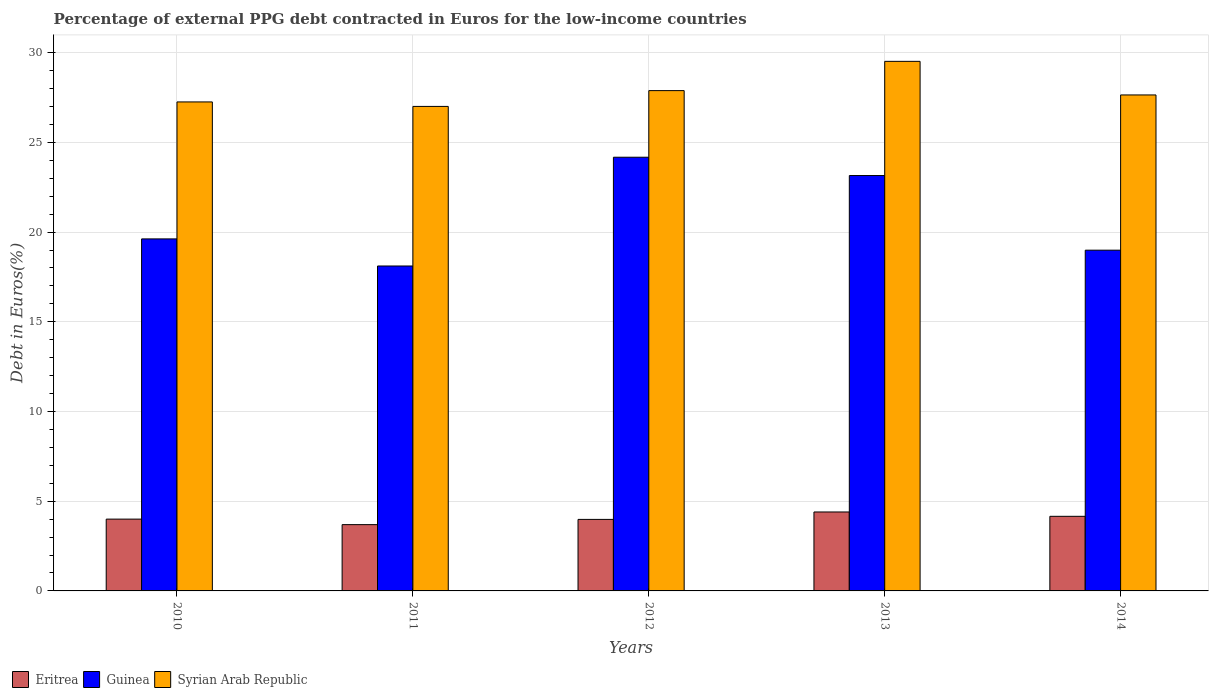How many different coloured bars are there?
Your answer should be very brief. 3. How many bars are there on the 1st tick from the right?
Provide a short and direct response. 3. In how many cases, is the number of bars for a given year not equal to the number of legend labels?
Offer a terse response. 0. What is the percentage of external PPG debt contracted in Euros in Syrian Arab Republic in 2011?
Provide a succinct answer. 27. Across all years, what is the maximum percentage of external PPG debt contracted in Euros in Guinea?
Provide a succinct answer. 24.17. Across all years, what is the minimum percentage of external PPG debt contracted in Euros in Syrian Arab Republic?
Offer a very short reply. 27. What is the total percentage of external PPG debt contracted in Euros in Guinea in the graph?
Make the answer very short. 104.04. What is the difference between the percentage of external PPG debt contracted in Euros in Syrian Arab Republic in 2012 and that in 2013?
Keep it short and to the point. -1.63. What is the difference between the percentage of external PPG debt contracted in Euros in Syrian Arab Republic in 2010 and the percentage of external PPG debt contracted in Euros in Guinea in 2014?
Offer a very short reply. 8.26. What is the average percentage of external PPG debt contracted in Euros in Syrian Arab Republic per year?
Your response must be concise. 27.86. In the year 2012, what is the difference between the percentage of external PPG debt contracted in Euros in Eritrea and percentage of external PPG debt contracted in Euros in Syrian Arab Republic?
Your answer should be compact. -23.9. What is the ratio of the percentage of external PPG debt contracted in Euros in Guinea in 2010 to that in 2012?
Your response must be concise. 0.81. Is the percentage of external PPG debt contracted in Euros in Guinea in 2013 less than that in 2014?
Your answer should be compact. No. What is the difference between the highest and the second highest percentage of external PPG debt contracted in Euros in Syrian Arab Republic?
Make the answer very short. 1.63. What is the difference between the highest and the lowest percentage of external PPG debt contracted in Euros in Eritrea?
Your answer should be compact. 0.71. What does the 3rd bar from the left in 2013 represents?
Keep it short and to the point. Syrian Arab Republic. What does the 2nd bar from the right in 2012 represents?
Offer a very short reply. Guinea. Are all the bars in the graph horizontal?
Provide a short and direct response. No. Are the values on the major ticks of Y-axis written in scientific E-notation?
Keep it short and to the point. No. How many legend labels are there?
Give a very brief answer. 3. What is the title of the graph?
Give a very brief answer. Percentage of external PPG debt contracted in Euros for the low-income countries. Does "Lithuania" appear as one of the legend labels in the graph?
Offer a terse response. No. What is the label or title of the Y-axis?
Your response must be concise. Debt in Euros(%). What is the Debt in Euros(%) of Eritrea in 2010?
Your response must be concise. 4. What is the Debt in Euros(%) of Guinea in 2010?
Your response must be concise. 19.62. What is the Debt in Euros(%) in Syrian Arab Republic in 2010?
Make the answer very short. 27.25. What is the Debt in Euros(%) in Eritrea in 2011?
Keep it short and to the point. 3.69. What is the Debt in Euros(%) of Guinea in 2011?
Offer a very short reply. 18.11. What is the Debt in Euros(%) in Syrian Arab Republic in 2011?
Offer a terse response. 27. What is the Debt in Euros(%) of Eritrea in 2012?
Your response must be concise. 3.99. What is the Debt in Euros(%) of Guinea in 2012?
Your answer should be compact. 24.17. What is the Debt in Euros(%) of Syrian Arab Republic in 2012?
Ensure brevity in your answer.  27.88. What is the Debt in Euros(%) of Eritrea in 2013?
Your response must be concise. 4.4. What is the Debt in Euros(%) in Guinea in 2013?
Your answer should be very brief. 23.15. What is the Debt in Euros(%) in Syrian Arab Republic in 2013?
Offer a terse response. 29.51. What is the Debt in Euros(%) in Eritrea in 2014?
Give a very brief answer. 4.16. What is the Debt in Euros(%) in Guinea in 2014?
Provide a succinct answer. 18.99. What is the Debt in Euros(%) in Syrian Arab Republic in 2014?
Ensure brevity in your answer.  27.64. Across all years, what is the maximum Debt in Euros(%) of Eritrea?
Offer a very short reply. 4.4. Across all years, what is the maximum Debt in Euros(%) of Guinea?
Provide a short and direct response. 24.17. Across all years, what is the maximum Debt in Euros(%) of Syrian Arab Republic?
Give a very brief answer. 29.51. Across all years, what is the minimum Debt in Euros(%) of Eritrea?
Ensure brevity in your answer.  3.69. Across all years, what is the minimum Debt in Euros(%) of Guinea?
Provide a short and direct response. 18.11. Across all years, what is the minimum Debt in Euros(%) in Syrian Arab Republic?
Provide a succinct answer. 27. What is the total Debt in Euros(%) in Eritrea in the graph?
Make the answer very short. 20.24. What is the total Debt in Euros(%) in Guinea in the graph?
Provide a short and direct response. 104.04. What is the total Debt in Euros(%) in Syrian Arab Republic in the graph?
Give a very brief answer. 139.3. What is the difference between the Debt in Euros(%) in Eritrea in 2010 and that in 2011?
Ensure brevity in your answer.  0.31. What is the difference between the Debt in Euros(%) in Guinea in 2010 and that in 2011?
Your answer should be very brief. 1.51. What is the difference between the Debt in Euros(%) of Syrian Arab Republic in 2010 and that in 2011?
Make the answer very short. 0.25. What is the difference between the Debt in Euros(%) in Eritrea in 2010 and that in 2012?
Your answer should be very brief. 0.02. What is the difference between the Debt in Euros(%) of Guinea in 2010 and that in 2012?
Ensure brevity in your answer.  -4.55. What is the difference between the Debt in Euros(%) in Syrian Arab Republic in 2010 and that in 2012?
Your answer should be very brief. -0.63. What is the difference between the Debt in Euros(%) in Eritrea in 2010 and that in 2013?
Your answer should be very brief. -0.4. What is the difference between the Debt in Euros(%) of Guinea in 2010 and that in 2013?
Offer a terse response. -3.53. What is the difference between the Debt in Euros(%) of Syrian Arab Republic in 2010 and that in 2013?
Your response must be concise. -2.26. What is the difference between the Debt in Euros(%) in Eritrea in 2010 and that in 2014?
Provide a short and direct response. -0.16. What is the difference between the Debt in Euros(%) of Guinea in 2010 and that in 2014?
Keep it short and to the point. 0.63. What is the difference between the Debt in Euros(%) of Syrian Arab Republic in 2010 and that in 2014?
Your answer should be compact. -0.39. What is the difference between the Debt in Euros(%) of Eritrea in 2011 and that in 2012?
Provide a succinct answer. -0.29. What is the difference between the Debt in Euros(%) in Guinea in 2011 and that in 2012?
Provide a succinct answer. -6.06. What is the difference between the Debt in Euros(%) of Syrian Arab Republic in 2011 and that in 2012?
Keep it short and to the point. -0.88. What is the difference between the Debt in Euros(%) in Eritrea in 2011 and that in 2013?
Make the answer very short. -0.71. What is the difference between the Debt in Euros(%) in Guinea in 2011 and that in 2013?
Ensure brevity in your answer.  -5.04. What is the difference between the Debt in Euros(%) of Syrian Arab Republic in 2011 and that in 2013?
Offer a terse response. -2.51. What is the difference between the Debt in Euros(%) of Eritrea in 2011 and that in 2014?
Ensure brevity in your answer.  -0.46. What is the difference between the Debt in Euros(%) of Guinea in 2011 and that in 2014?
Ensure brevity in your answer.  -0.88. What is the difference between the Debt in Euros(%) in Syrian Arab Republic in 2011 and that in 2014?
Your response must be concise. -0.64. What is the difference between the Debt in Euros(%) in Eritrea in 2012 and that in 2013?
Keep it short and to the point. -0.41. What is the difference between the Debt in Euros(%) in Guinea in 2012 and that in 2013?
Your answer should be very brief. 1.02. What is the difference between the Debt in Euros(%) of Syrian Arab Republic in 2012 and that in 2013?
Your answer should be very brief. -1.63. What is the difference between the Debt in Euros(%) of Eritrea in 2012 and that in 2014?
Ensure brevity in your answer.  -0.17. What is the difference between the Debt in Euros(%) of Guinea in 2012 and that in 2014?
Offer a very short reply. 5.18. What is the difference between the Debt in Euros(%) in Syrian Arab Republic in 2012 and that in 2014?
Give a very brief answer. 0.24. What is the difference between the Debt in Euros(%) in Eritrea in 2013 and that in 2014?
Your answer should be compact. 0.24. What is the difference between the Debt in Euros(%) of Guinea in 2013 and that in 2014?
Offer a very short reply. 4.16. What is the difference between the Debt in Euros(%) in Syrian Arab Republic in 2013 and that in 2014?
Offer a very short reply. 1.87. What is the difference between the Debt in Euros(%) in Eritrea in 2010 and the Debt in Euros(%) in Guinea in 2011?
Your answer should be compact. -14.11. What is the difference between the Debt in Euros(%) in Eritrea in 2010 and the Debt in Euros(%) in Syrian Arab Republic in 2011?
Make the answer very short. -23. What is the difference between the Debt in Euros(%) in Guinea in 2010 and the Debt in Euros(%) in Syrian Arab Republic in 2011?
Give a very brief answer. -7.38. What is the difference between the Debt in Euros(%) of Eritrea in 2010 and the Debt in Euros(%) of Guinea in 2012?
Make the answer very short. -20.17. What is the difference between the Debt in Euros(%) in Eritrea in 2010 and the Debt in Euros(%) in Syrian Arab Republic in 2012?
Offer a terse response. -23.88. What is the difference between the Debt in Euros(%) of Guinea in 2010 and the Debt in Euros(%) of Syrian Arab Republic in 2012?
Your response must be concise. -8.26. What is the difference between the Debt in Euros(%) of Eritrea in 2010 and the Debt in Euros(%) of Guinea in 2013?
Keep it short and to the point. -19.15. What is the difference between the Debt in Euros(%) in Eritrea in 2010 and the Debt in Euros(%) in Syrian Arab Republic in 2013?
Offer a terse response. -25.51. What is the difference between the Debt in Euros(%) of Guinea in 2010 and the Debt in Euros(%) of Syrian Arab Republic in 2013?
Your answer should be very brief. -9.9. What is the difference between the Debt in Euros(%) of Eritrea in 2010 and the Debt in Euros(%) of Guinea in 2014?
Offer a very short reply. -14.99. What is the difference between the Debt in Euros(%) of Eritrea in 2010 and the Debt in Euros(%) of Syrian Arab Republic in 2014?
Keep it short and to the point. -23.64. What is the difference between the Debt in Euros(%) of Guinea in 2010 and the Debt in Euros(%) of Syrian Arab Republic in 2014?
Provide a succinct answer. -8.02. What is the difference between the Debt in Euros(%) in Eritrea in 2011 and the Debt in Euros(%) in Guinea in 2012?
Provide a succinct answer. -20.48. What is the difference between the Debt in Euros(%) of Eritrea in 2011 and the Debt in Euros(%) of Syrian Arab Republic in 2012?
Make the answer very short. -24.19. What is the difference between the Debt in Euros(%) of Guinea in 2011 and the Debt in Euros(%) of Syrian Arab Republic in 2012?
Keep it short and to the point. -9.77. What is the difference between the Debt in Euros(%) of Eritrea in 2011 and the Debt in Euros(%) of Guinea in 2013?
Provide a short and direct response. -19.46. What is the difference between the Debt in Euros(%) in Eritrea in 2011 and the Debt in Euros(%) in Syrian Arab Republic in 2013?
Offer a terse response. -25.82. What is the difference between the Debt in Euros(%) of Guinea in 2011 and the Debt in Euros(%) of Syrian Arab Republic in 2013?
Your answer should be very brief. -11.4. What is the difference between the Debt in Euros(%) of Eritrea in 2011 and the Debt in Euros(%) of Guinea in 2014?
Give a very brief answer. -15.3. What is the difference between the Debt in Euros(%) in Eritrea in 2011 and the Debt in Euros(%) in Syrian Arab Republic in 2014?
Make the answer very short. -23.95. What is the difference between the Debt in Euros(%) of Guinea in 2011 and the Debt in Euros(%) of Syrian Arab Republic in 2014?
Make the answer very short. -9.53. What is the difference between the Debt in Euros(%) of Eritrea in 2012 and the Debt in Euros(%) of Guinea in 2013?
Your answer should be compact. -19.16. What is the difference between the Debt in Euros(%) of Eritrea in 2012 and the Debt in Euros(%) of Syrian Arab Republic in 2013?
Offer a terse response. -25.53. What is the difference between the Debt in Euros(%) in Guinea in 2012 and the Debt in Euros(%) in Syrian Arab Republic in 2013?
Your response must be concise. -5.34. What is the difference between the Debt in Euros(%) in Eritrea in 2012 and the Debt in Euros(%) in Guinea in 2014?
Your answer should be compact. -15.01. What is the difference between the Debt in Euros(%) of Eritrea in 2012 and the Debt in Euros(%) of Syrian Arab Republic in 2014?
Offer a very short reply. -23.66. What is the difference between the Debt in Euros(%) of Guinea in 2012 and the Debt in Euros(%) of Syrian Arab Republic in 2014?
Your answer should be very brief. -3.47. What is the difference between the Debt in Euros(%) of Eritrea in 2013 and the Debt in Euros(%) of Guinea in 2014?
Keep it short and to the point. -14.59. What is the difference between the Debt in Euros(%) of Eritrea in 2013 and the Debt in Euros(%) of Syrian Arab Republic in 2014?
Ensure brevity in your answer.  -23.24. What is the difference between the Debt in Euros(%) of Guinea in 2013 and the Debt in Euros(%) of Syrian Arab Republic in 2014?
Keep it short and to the point. -4.49. What is the average Debt in Euros(%) of Eritrea per year?
Provide a short and direct response. 4.05. What is the average Debt in Euros(%) in Guinea per year?
Keep it short and to the point. 20.81. What is the average Debt in Euros(%) in Syrian Arab Republic per year?
Offer a terse response. 27.86. In the year 2010, what is the difference between the Debt in Euros(%) of Eritrea and Debt in Euros(%) of Guinea?
Your answer should be very brief. -15.62. In the year 2010, what is the difference between the Debt in Euros(%) of Eritrea and Debt in Euros(%) of Syrian Arab Republic?
Your answer should be compact. -23.25. In the year 2010, what is the difference between the Debt in Euros(%) of Guinea and Debt in Euros(%) of Syrian Arab Republic?
Make the answer very short. -7.63. In the year 2011, what is the difference between the Debt in Euros(%) of Eritrea and Debt in Euros(%) of Guinea?
Offer a terse response. -14.41. In the year 2011, what is the difference between the Debt in Euros(%) of Eritrea and Debt in Euros(%) of Syrian Arab Republic?
Your answer should be very brief. -23.31. In the year 2011, what is the difference between the Debt in Euros(%) in Guinea and Debt in Euros(%) in Syrian Arab Republic?
Ensure brevity in your answer.  -8.89. In the year 2012, what is the difference between the Debt in Euros(%) of Eritrea and Debt in Euros(%) of Guinea?
Make the answer very short. -20.18. In the year 2012, what is the difference between the Debt in Euros(%) of Eritrea and Debt in Euros(%) of Syrian Arab Republic?
Your answer should be very brief. -23.9. In the year 2012, what is the difference between the Debt in Euros(%) of Guinea and Debt in Euros(%) of Syrian Arab Republic?
Offer a terse response. -3.71. In the year 2013, what is the difference between the Debt in Euros(%) of Eritrea and Debt in Euros(%) of Guinea?
Make the answer very short. -18.75. In the year 2013, what is the difference between the Debt in Euros(%) of Eritrea and Debt in Euros(%) of Syrian Arab Republic?
Provide a short and direct response. -25.11. In the year 2013, what is the difference between the Debt in Euros(%) in Guinea and Debt in Euros(%) in Syrian Arab Republic?
Your response must be concise. -6.36. In the year 2014, what is the difference between the Debt in Euros(%) in Eritrea and Debt in Euros(%) in Guinea?
Provide a succinct answer. -14.83. In the year 2014, what is the difference between the Debt in Euros(%) of Eritrea and Debt in Euros(%) of Syrian Arab Republic?
Your answer should be compact. -23.48. In the year 2014, what is the difference between the Debt in Euros(%) in Guinea and Debt in Euros(%) in Syrian Arab Republic?
Provide a short and direct response. -8.65. What is the ratio of the Debt in Euros(%) in Eritrea in 2010 to that in 2011?
Your response must be concise. 1.08. What is the ratio of the Debt in Euros(%) of Guinea in 2010 to that in 2011?
Your response must be concise. 1.08. What is the ratio of the Debt in Euros(%) of Syrian Arab Republic in 2010 to that in 2011?
Your answer should be compact. 1.01. What is the ratio of the Debt in Euros(%) of Guinea in 2010 to that in 2012?
Make the answer very short. 0.81. What is the ratio of the Debt in Euros(%) of Syrian Arab Republic in 2010 to that in 2012?
Offer a very short reply. 0.98. What is the ratio of the Debt in Euros(%) of Eritrea in 2010 to that in 2013?
Offer a terse response. 0.91. What is the ratio of the Debt in Euros(%) in Guinea in 2010 to that in 2013?
Give a very brief answer. 0.85. What is the ratio of the Debt in Euros(%) in Syrian Arab Republic in 2010 to that in 2013?
Provide a succinct answer. 0.92. What is the ratio of the Debt in Euros(%) in Eritrea in 2010 to that in 2014?
Your answer should be very brief. 0.96. What is the ratio of the Debt in Euros(%) of Guinea in 2010 to that in 2014?
Offer a very short reply. 1.03. What is the ratio of the Debt in Euros(%) in Syrian Arab Republic in 2010 to that in 2014?
Make the answer very short. 0.99. What is the ratio of the Debt in Euros(%) in Eritrea in 2011 to that in 2012?
Offer a very short reply. 0.93. What is the ratio of the Debt in Euros(%) of Guinea in 2011 to that in 2012?
Your response must be concise. 0.75. What is the ratio of the Debt in Euros(%) in Syrian Arab Republic in 2011 to that in 2012?
Offer a very short reply. 0.97. What is the ratio of the Debt in Euros(%) in Eritrea in 2011 to that in 2013?
Your answer should be very brief. 0.84. What is the ratio of the Debt in Euros(%) of Guinea in 2011 to that in 2013?
Offer a very short reply. 0.78. What is the ratio of the Debt in Euros(%) in Syrian Arab Republic in 2011 to that in 2013?
Keep it short and to the point. 0.91. What is the ratio of the Debt in Euros(%) in Eritrea in 2011 to that in 2014?
Offer a terse response. 0.89. What is the ratio of the Debt in Euros(%) of Guinea in 2011 to that in 2014?
Your response must be concise. 0.95. What is the ratio of the Debt in Euros(%) in Syrian Arab Republic in 2011 to that in 2014?
Provide a succinct answer. 0.98. What is the ratio of the Debt in Euros(%) of Eritrea in 2012 to that in 2013?
Provide a short and direct response. 0.91. What is the ratio of the Debt in Euros(%) in Guinea in 2012 to that in 2013?
Your answer should be very brief. 1.04. What is the ratio of the Debt in Euros(%) in Syrian Arab Republic in 2012 to that in 2013?
Provide a short and direct response. 0.94. What is the ratio of the Debt in Euros(%) in Eritrea in 2012 to that in 2014?
Keep it short and to the point. 0.96. What is the ratio of the Debt in Euros(%) in Guinea in 2012 to that in 2014?
Ensure brevity in your answer.  1.27. What is the ratio of the Debt in Euros(%) of Syrian Arab Republic in 2012 to that in 2014?
Offer a terse response. 1.01. What is the ratio of the Debt in Euros(%) in Eritrea in 2013 to that in 2014?
Give a very brief answer. 1.06. What is the ratio of the Debt in Euros(%) in Guinea in 2013 to that in 2014?
Keep it short and to the point. 1.22. What is the ratio of the Debt in Euros(%) of Syrian Arab Republic in 2013 to that in 2014?
Provide a succinct answer. 1.07. What is the difference between the highest and the second highest Debt in Euros(%) of Eritrea?
Your answer should be compact. 0.24. What is the difference between the highest and the second highest Debt in Euros(%) of Guinea?
Offer a terse response. 1.02. What is the difference between the highest and the second highest Debt in Euros(%) in Syrian Arab Republic?
Provide a succinct answer. 1.63. What is the difference between the highest and the lowest Debt in Euros(%) of Eritrea?
Your response must be concise. 0.71. What is the difference between the highest and the lowest Debt in Euros(%) in Guinea?
Provide a succinct answer. 6.06. What is the difference between the highest and the lowest Debt in Euros(%) of Syrian Arab Republic?
Keep it short and to the point. 2.51. 